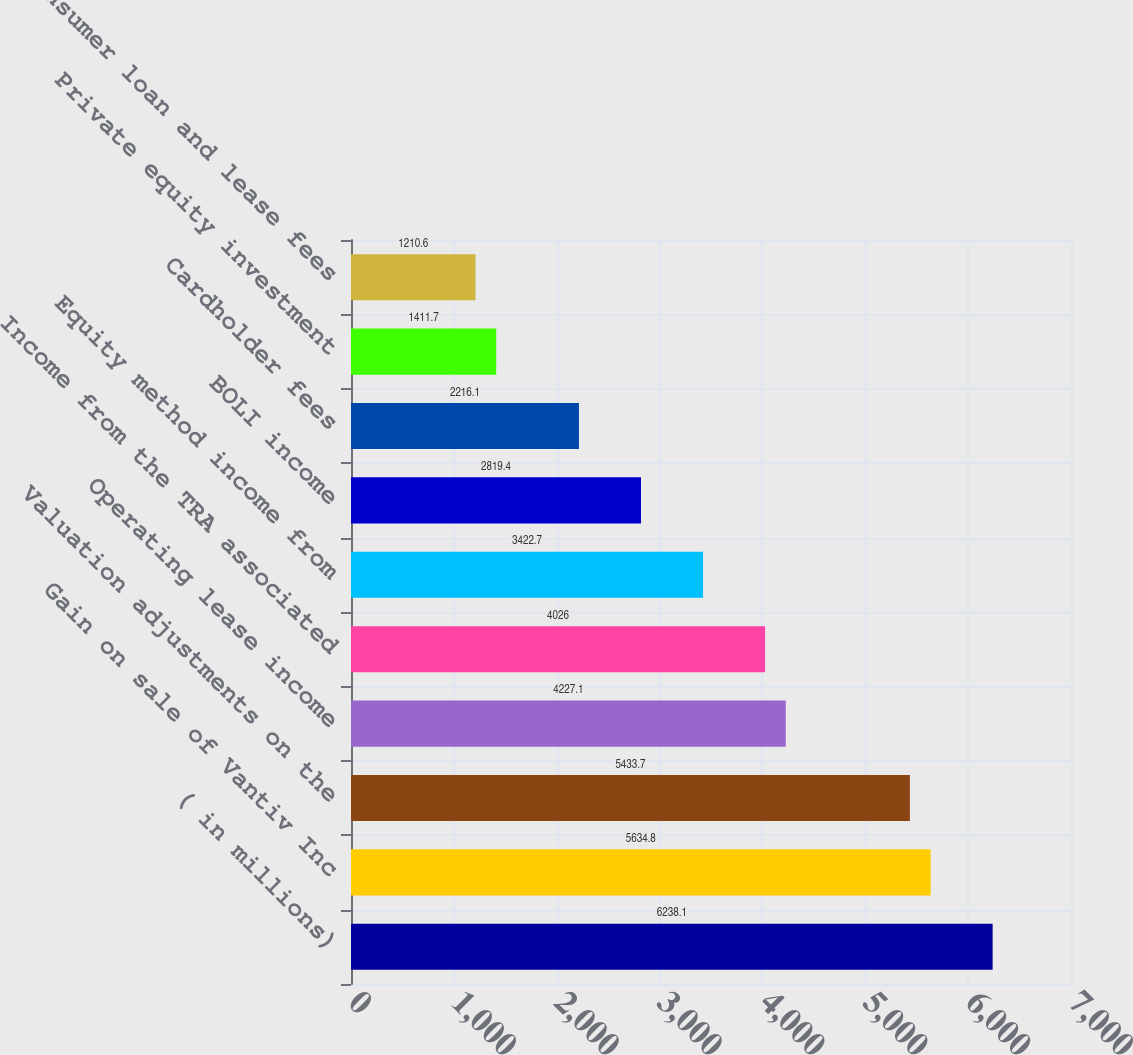Convert chart. <chart><loc_0><loc_0><loc_500><loc_500><bar_chart><fcel>( in millions)<fcel>Gain on sale of Vantiv Inc<fcel>Valuation adjustments on the<fcel>Operating lease income<fcel>Income from the TRA associated<fcel>Equity method income from<fcel>BOLI income<fcel>Cardholder fees<fcel>Private equity investment<fcel>Consumer loan and lease fees<nl><fcel>6238.1<fcel>5634.8<fcel>5433.7<fcel>4227.1<fcel>4026<fcel>3422.7<fcel>2819.4<fcel>2216.1<fcel>1411.7<fcel>1210.6<nl></chart> 